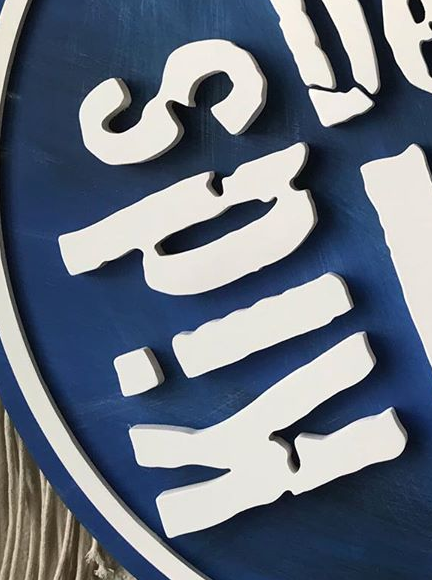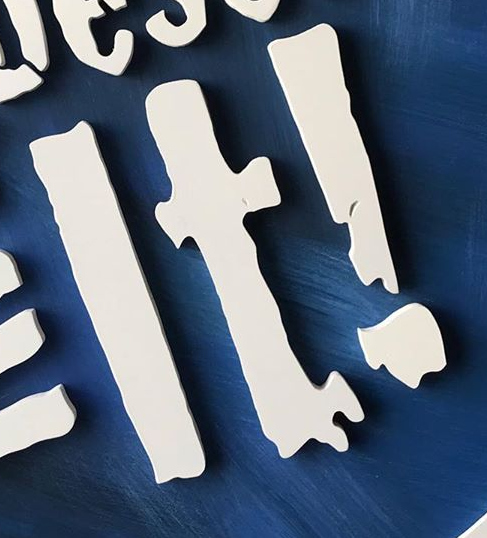Read the text from these images in sequence, separated by a semicolon. Kids; It! 